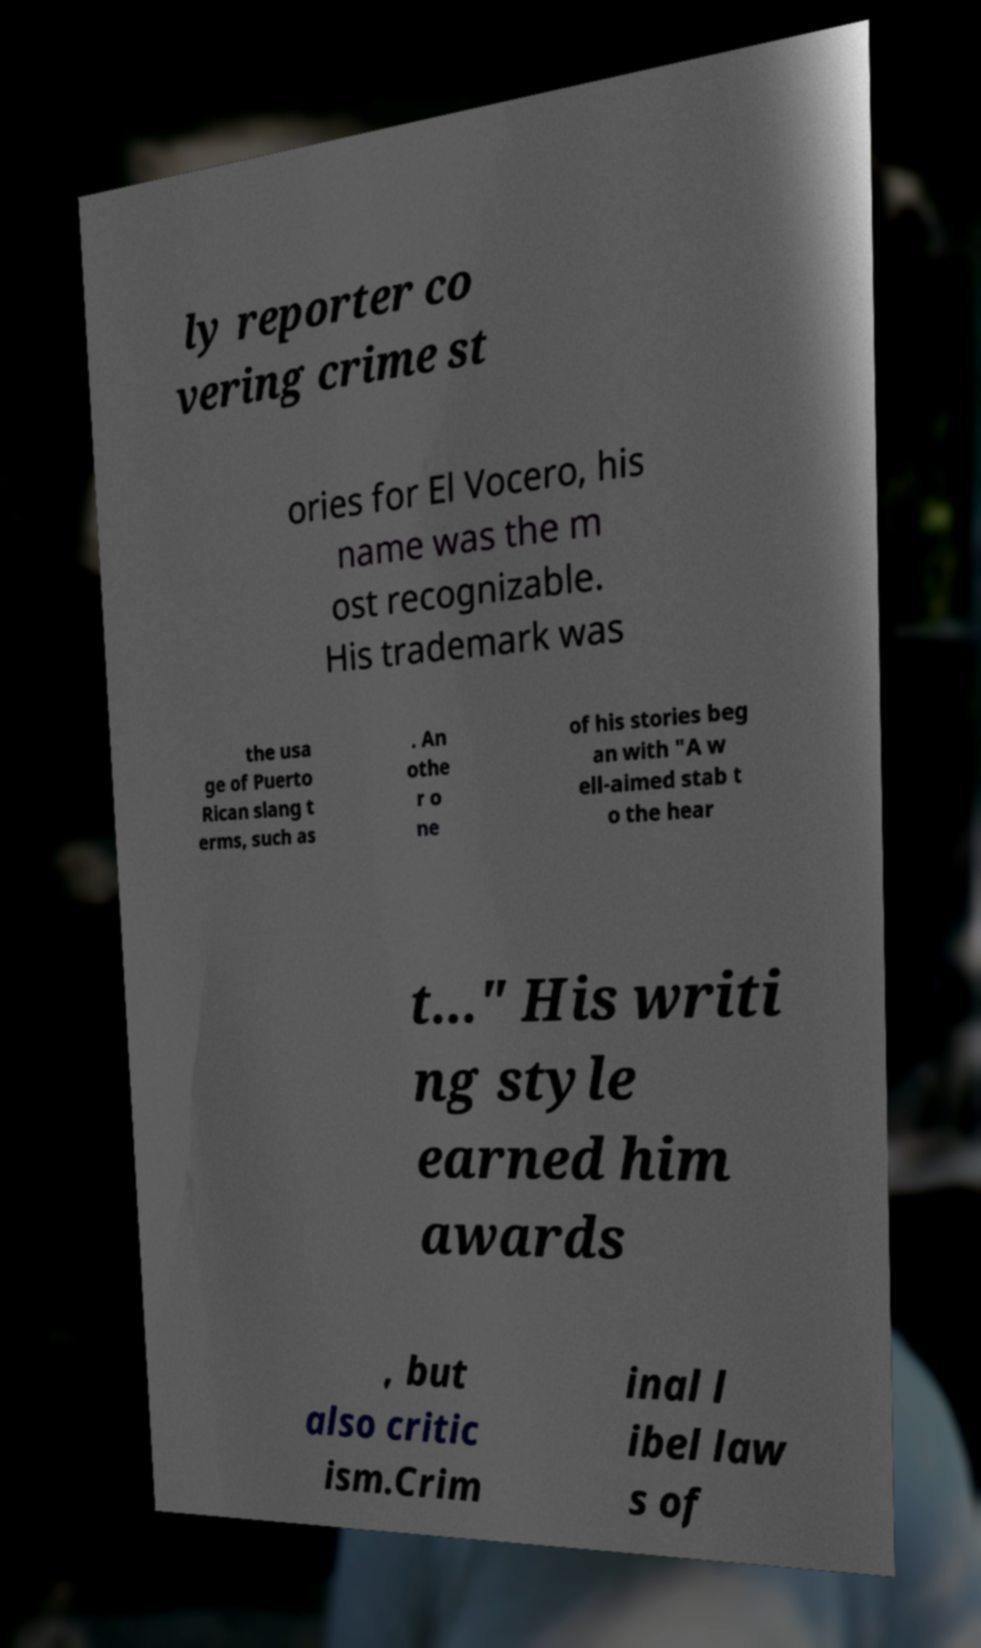Could you extract and type out the text from this image? ly reporter co vering crime st ories for El Vocero, his name was the m ost recognizable. His trademark was the usa ge of Puerto Rican slang t erms, such as . An othe r o ne of his stories beg an with "A w ell-aimed stab t o the hear t..." His writi ng style earned him awards , but also critic ism.Crim inal l ibel law s of 